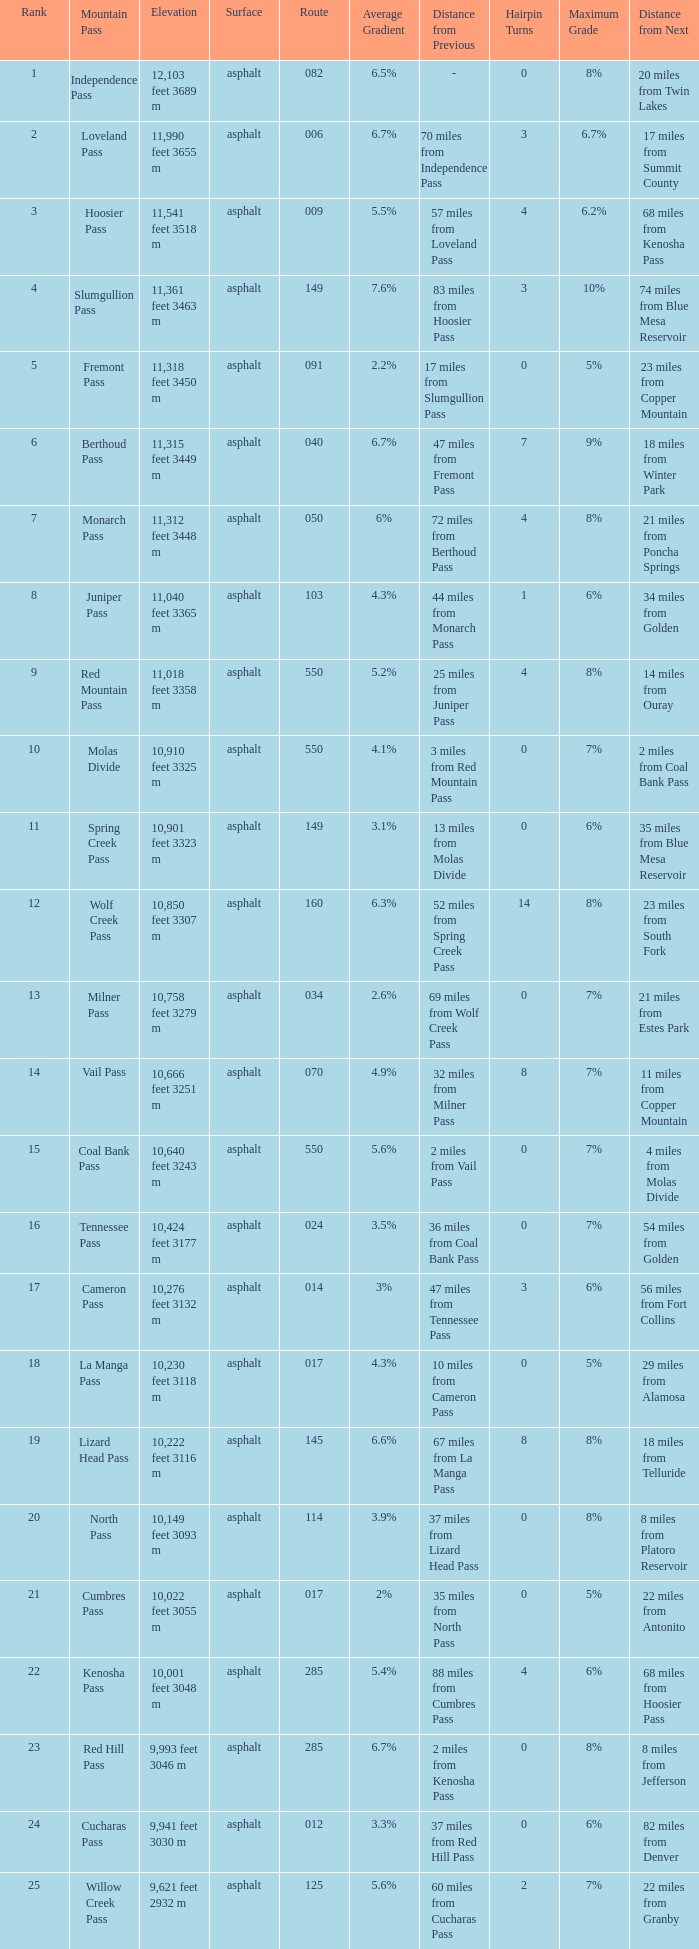What is the Mountain Pass with a 21 Rank? Cumbres Pass. 